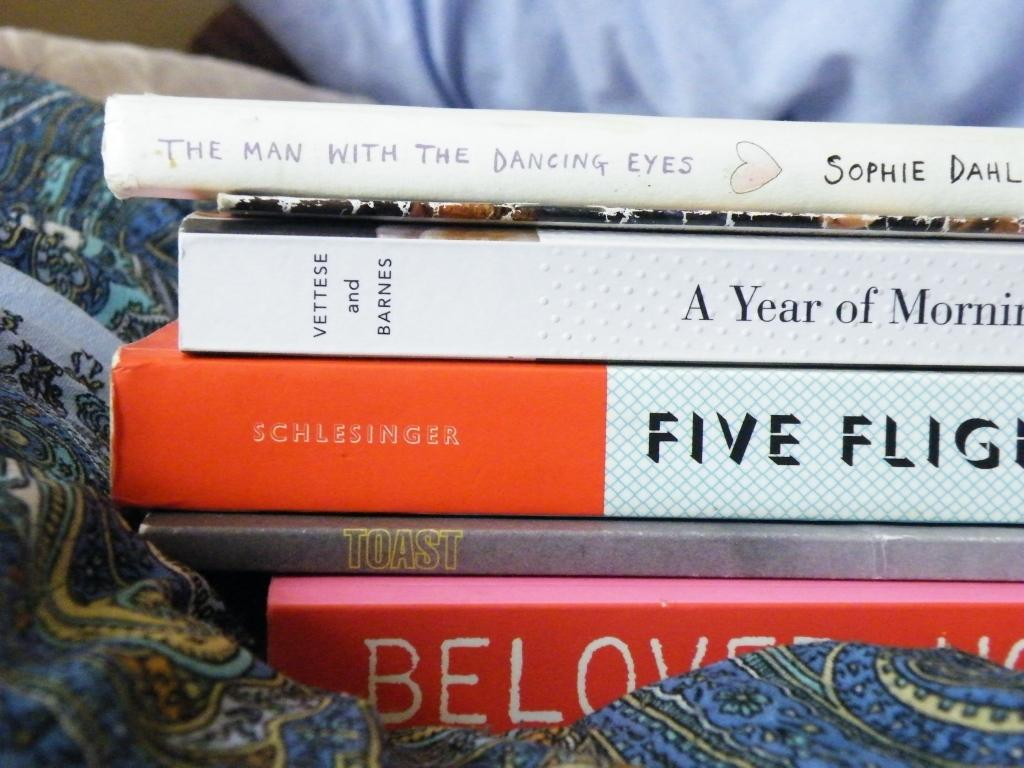<image>
Give a short and clear explanation of the subsequent image. several books like The Man with the Dancing Eyes stacked together 